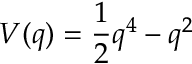<formula> <loc_0><loc_0><loc_500><loc_500>V ( q ) = \frac { 1 } { 2 } q ^ { 4 } - q ^ { 2 }</formula> 